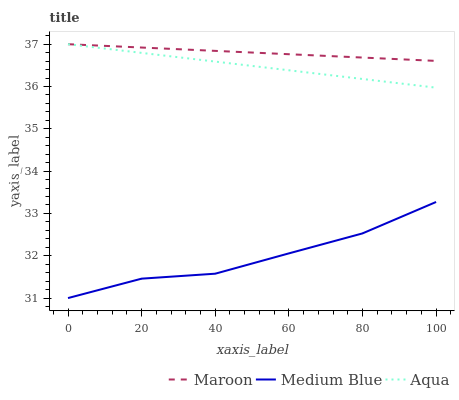Does Medium Blue have the minimum area under the curve?
Answer yes or no. Yes. Does Maroon have the maximum area under the curve?
Answer yes or no. Yes. Does Maroon have the minimum area under the curve?
Answer yes or no. No. Does Medium Blue have the maximum area under the curve?
Answer yes or no. No. Is Aqua the smoothest?
Answer yes or no. Yes. Is Medium Blue the roughest?
Answer yes or no. Yes. Is Medium Blue the smoothest?
Answer yes or no. No. Is Maroon the roughest?
Answer yes or no. No. Does Medium Blue have the lowest value?
Answer yes or no. Yes. Does Maroon have the lowest value?
Answer yes or no. No. Does Maroon have the highest value?
Answer yes or no. Yes. Does Medium Blue have the highest value?
Answer yes or no. No. Is Medium Blue less than Aqua?
Answer yes or no. Yes. Is Aqua greater than Medium Blue?
Answer yes or no. Yes. Does Aqua intersect Maroon?
Answer yes or no. Yes. Is Aqua less than Maroon?
Answer yes or no. No. Is Aqua greater than Maroon?
Answer yes or no. No. Does Medium Blue intersect Aqua?
Answer yes or no. No. 